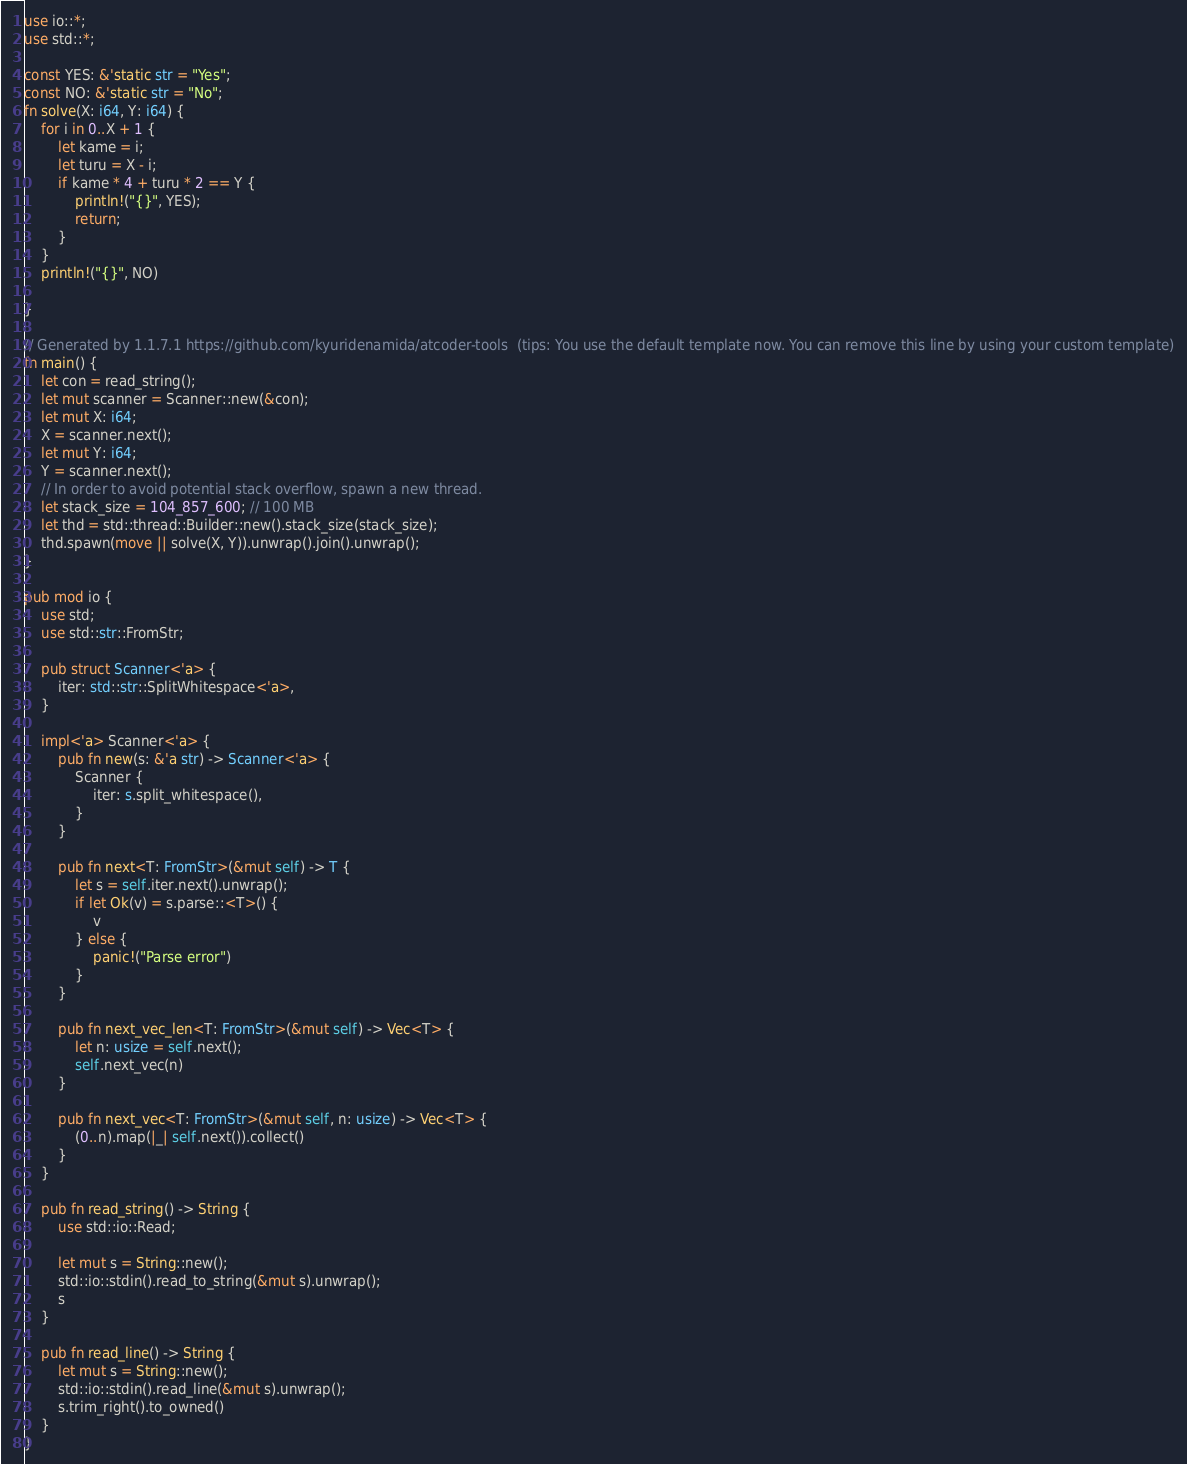Convert code to text. <code><loc_0><loc_0><loc_500><loc_500><_Rust_>use io::*;
use std::*;

const YES: &'static str = "Yes";
const NO: &'static str = "No";
fn solve(X: i64, Y: i64) {
    for i in 0..X + 1 {
        let kame = i;
        let turu = X - i;
        if kame * 4 + turu * 2 == Y {
            println!("{}", YES);
            return;
        }
    }
    println!("{}", NO)

}

// Generated by 1.1.7.1 https://github.com/kyuridenamida/atcoder-tools  (tips: You use the default template now. You can remove this line by using your custom template)
fn main() {
    let con = read_string();
    let mut scanner = Scanner::new(&con);
    let mut X: i64;
    X = scanner.next();
    let mut Y: i64;
    Y = scanner.next();
    // In order to avoid potential stack overflow, spawn a new thread.
    let stack_size = 104_857_600; // 100 MB
    let thd = std::thread::Builder::new().stack_size(stack_size);
    thd.spawn(move || solve(X, Y)).unwrap().join().unwrap();
}

pub mod io {
    use std;
    use std::str::FromStr;

    pub struct Scanner<'a> {
        iter: std::str::SplitWhitespace<'a>,
    }

    impl<'a> Scanner<'a> {
        pub fn new(s: &'a str) -> Scanner<'a> {
            Scanner {
                iter: s.split_whitespace(),
            }
        }

        pub fn next<T: FromStr>(&mut self) -> T {
            let s = self.iter.next().unwrap();
            if let Ok(v) = s.parse::<T>() {
                v
            } else {
                panic!("Parse error")
            }
        }

        pub fn next_vec_len<T: FromStr>(&mut self) -> Vec<T> {
            let n: usize = self.next();
            self.next_vec(n)
        }

        pub fn next_vec<T: FromStr>(&mut self, n: usize) -> Vec<T> {
            (0..n).map(|_| self.next()).collect()
        }
    }

    pub fn read_string() -> String {
        use std::io::Read;

        let mut s = String::new();
        std::io::stdin().read_to_string(&mut s).unwrap();
        s
    }

    pub fn read_line() -> String {
        let mut s = String::new();
        std::io::stdin().read_line(&mut s).unwrap();
        s.trim_right().to_owned()
    }
}
</code> 